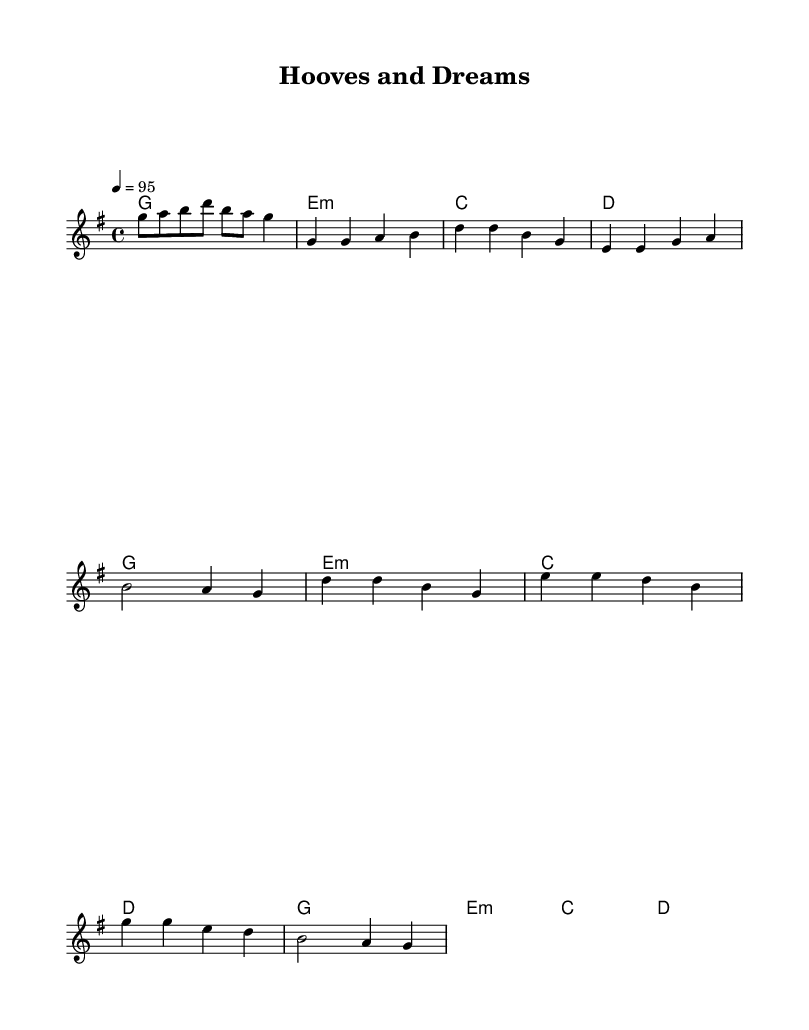What is the key signature of this music? The key signature is G major, which has one sharp (F#). This can be determined by checking the key signature indicated at the beginning of the staff.
Answer: G major What is the time signature of this music? The time signature is 4/4, which means there are four beats in a measure and the quarter note gets one beat. This is typically noted at the beginning of the score.
Answer: 4/4 What is the tempo marking for the piece? The tempo marking is quarter note = 95, indicating that the piece should be played at a speed of 95 quarter notes per minute. This is specified under the tempo directive in the score.
Answer: 95 How many measures are in the verse? There are four measures in the verse section, which can be counted by looking at the staff where the verse lyrics are aligned with the melody notes.
Answer: Four What is the primary theme expressed in the chorus lyrics? The primary theme expressed in the chorus lyrics is perseverance and ambition, reflected in phrases like "Ridin' high, never gonna stop." This shows the aspiration to succeed, which resonates with the overall message of pursuing dreams.
Answer: Perseverance Which chord follows the chorus melody? After the chorus melody, the chord progression is G major for the next repetition, which is discernible from the chord names aligned with the melody. This helps identify the cyclical nature in the song’s structure.
Answer: G major 